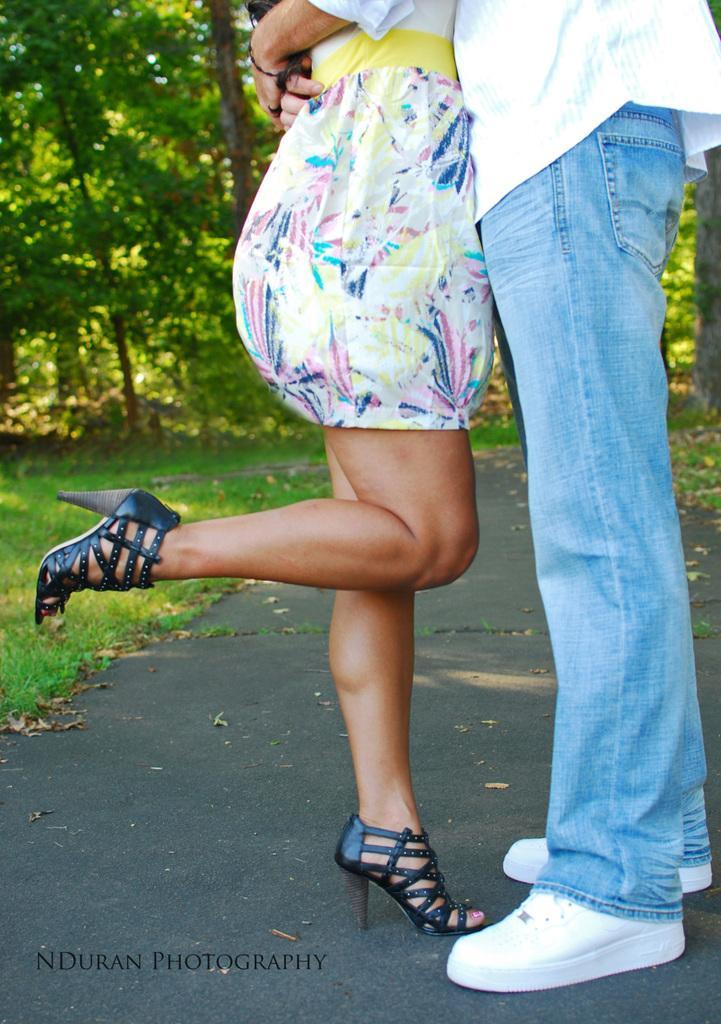How would you summarize this image in a sentence or two? In this picture we can see two persons are standing in the front, on the left side there is grass, we can see trees in the background. 